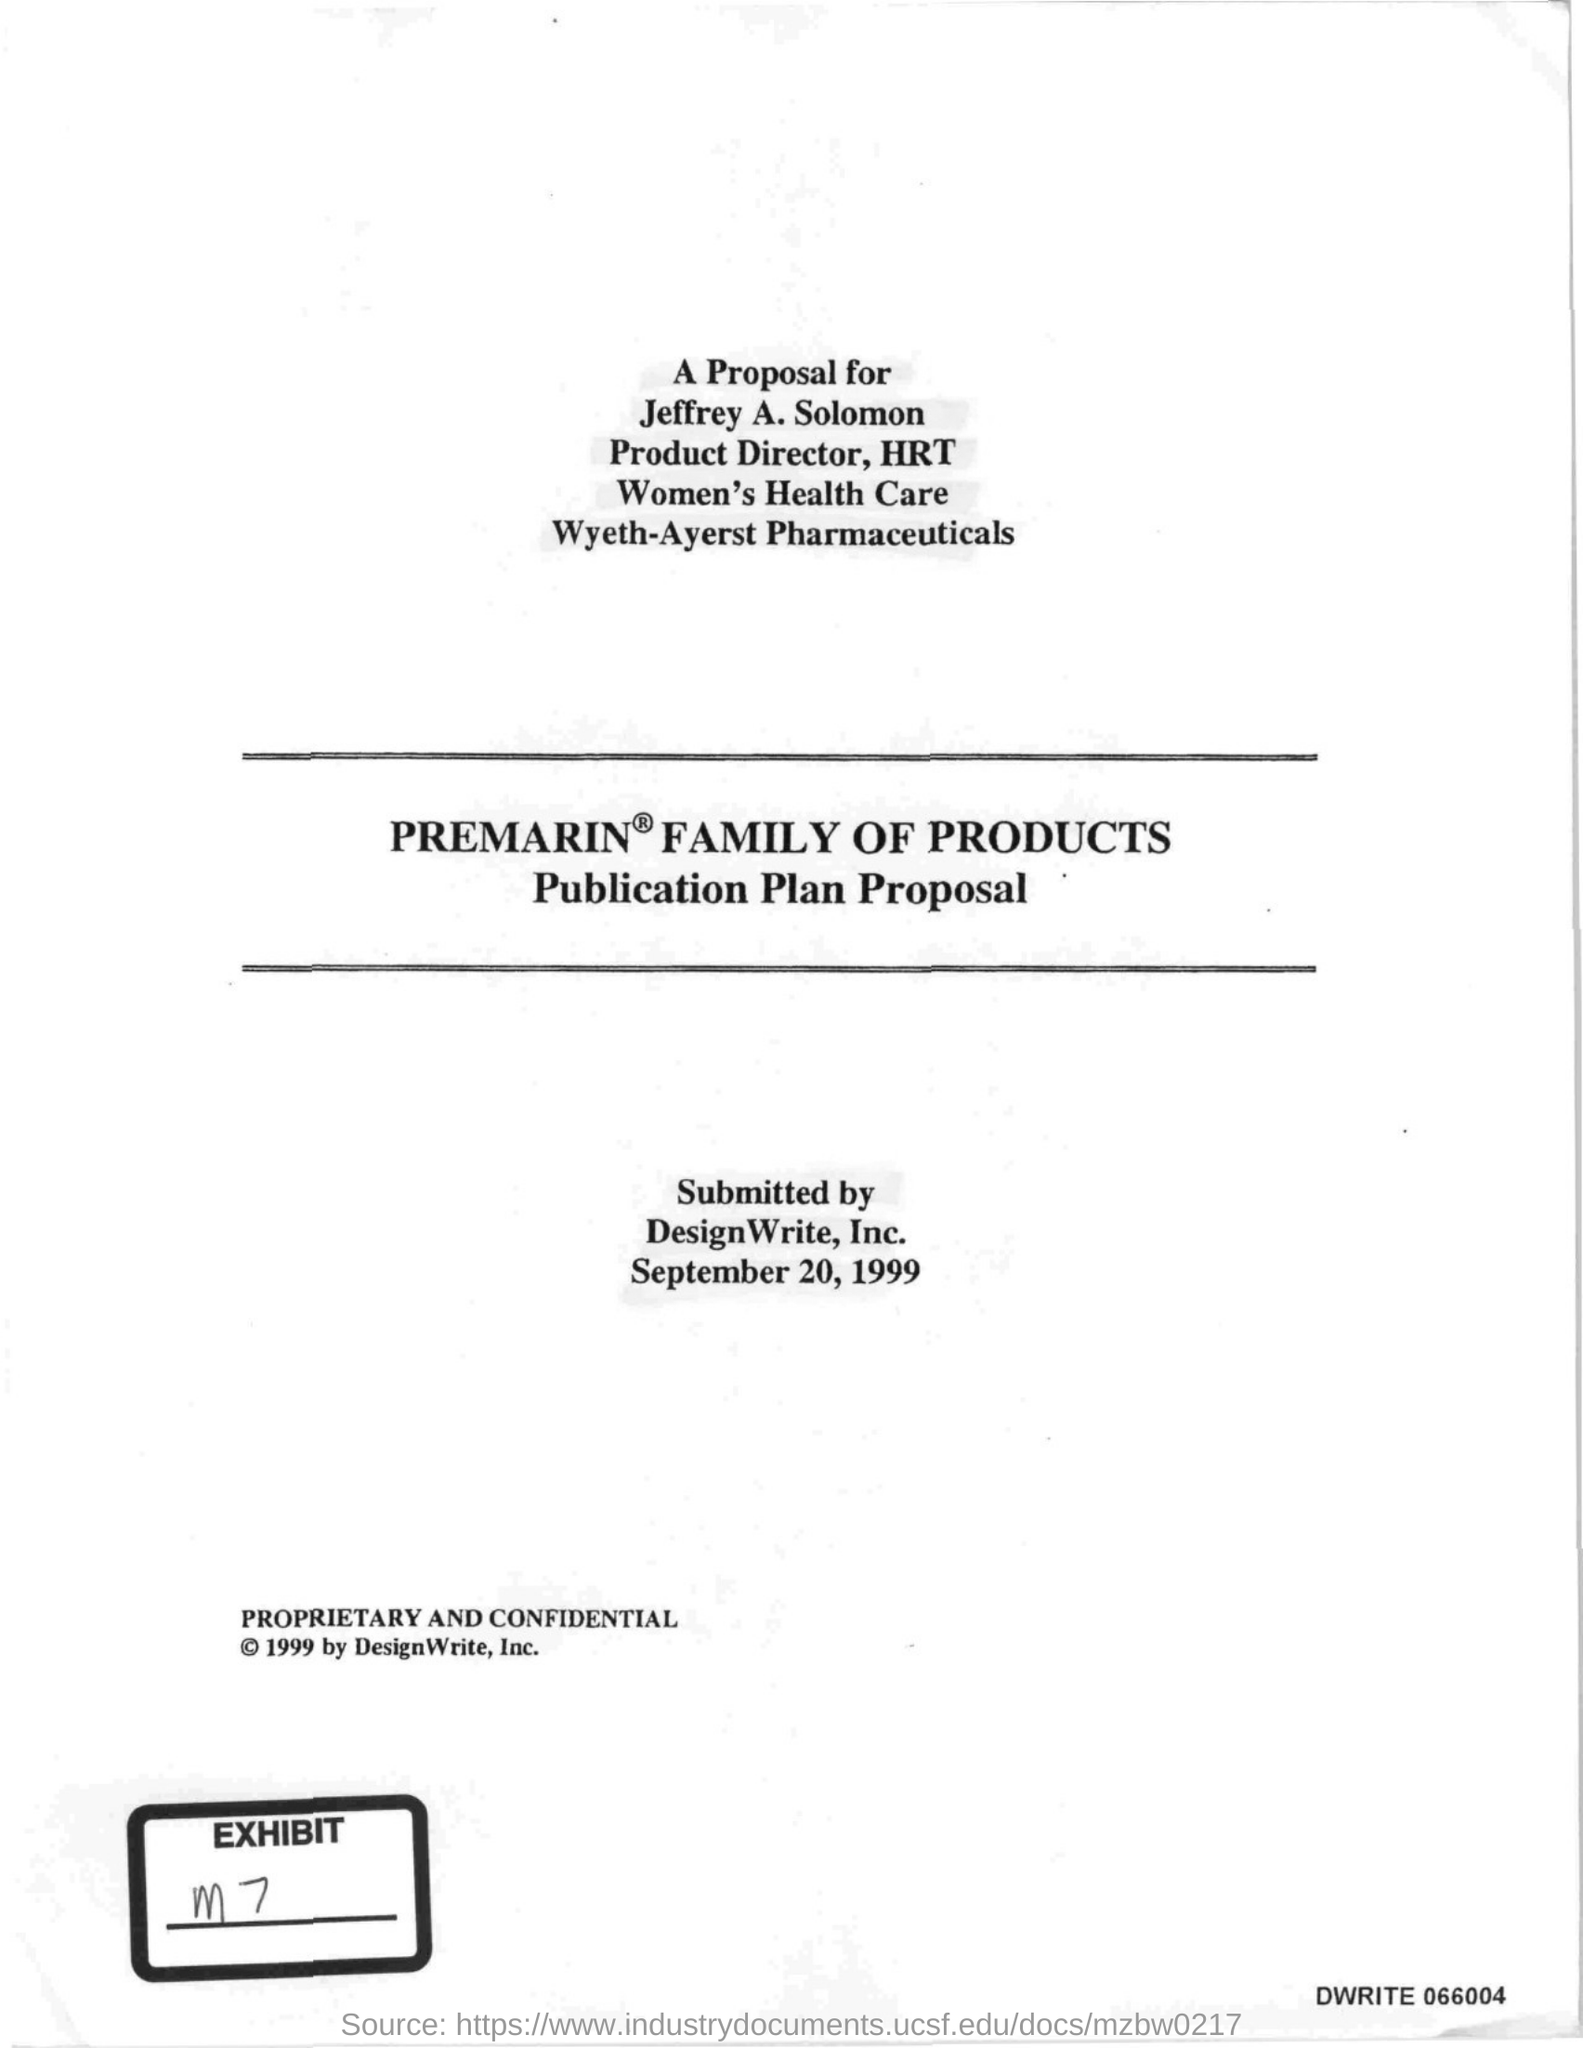Point out several critical features in this image. The proposal is intended for Jeffrey A. Solomon. The proposal was submitted on September 20, 1999. The proposal was submitted by DesignWrite, Inc. 